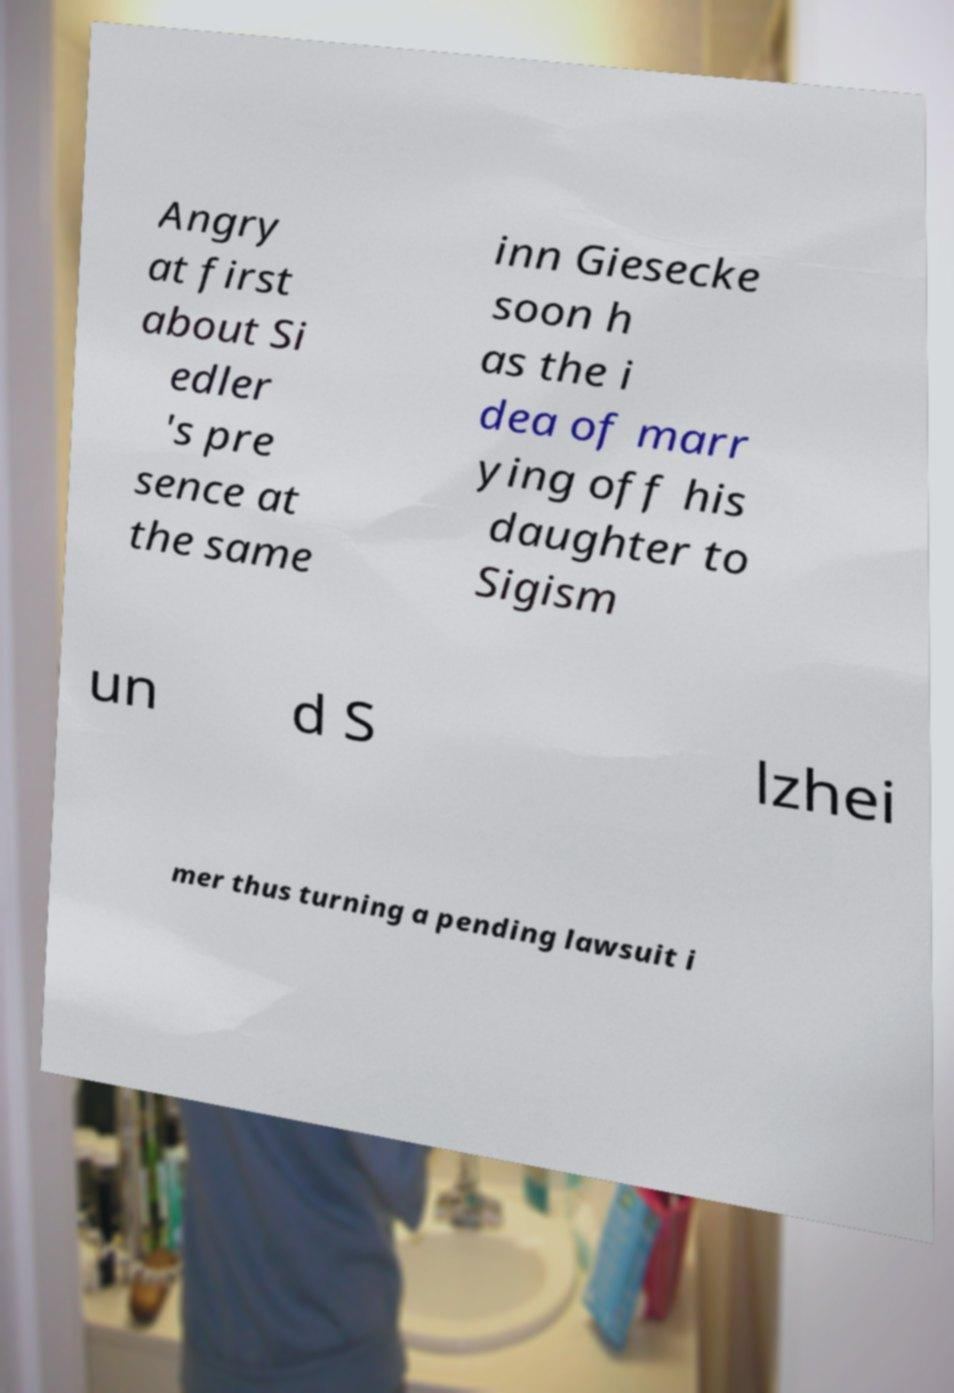Can you accurately transcribe the text from the provided image for me? Angry at first about Si edler 's pre sence at the same inn Giesecke soon h as the i dea of marr ying off his daughter to Sigism un d S lzhei mer thus turning a pending lawsuit i 